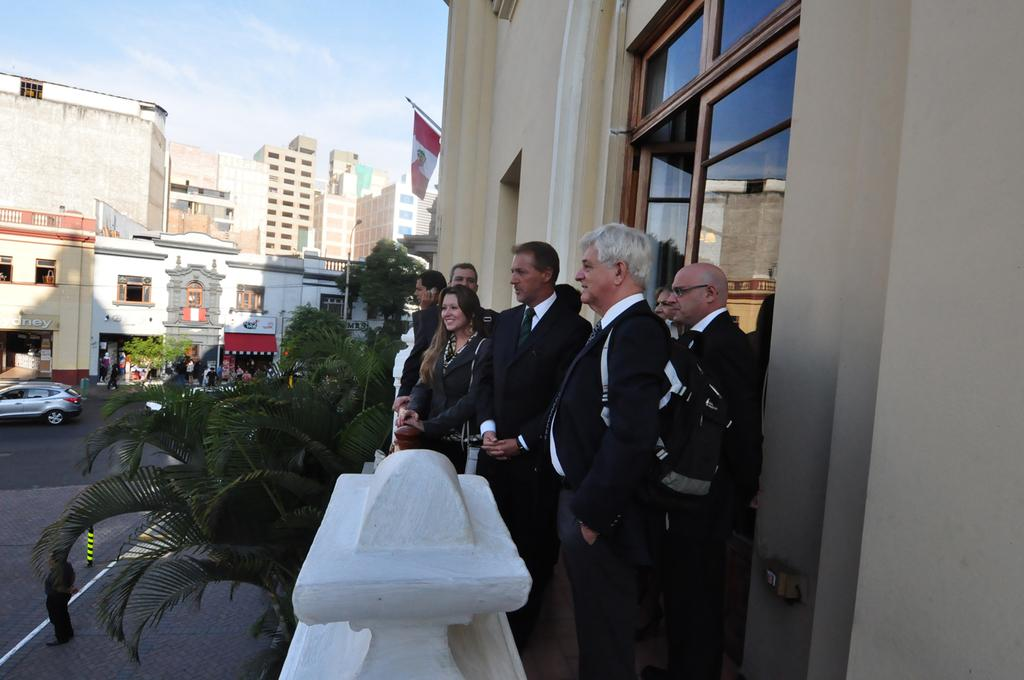How many people are present in the image? There are few persons in the image. What else can be seen in the image besides the people? There are plants, poles, boards, a flag, buildings, a car on the road, and the sky visible in the background of the image. What type of cloth is being used to cover the cannon in the image? There is no cannon present in the image, so cloth is not being used to cover any cannon. 